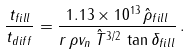Convert formula to latex. <formula><loc_0><loc_0><loc_500><loc_500>\frac { t _ { f i l l } } { t _ { d i f f } } = \frac { 1 . 1 3 \times 1 0 ^ { 1 3 } \, \hat { \rho } _ { f i l l } } { r \, \rho v _ { n } \, \hat { T } ^ { 3 / 2 } \, \tan \delta _ { f i l l } } \, .</formula> 